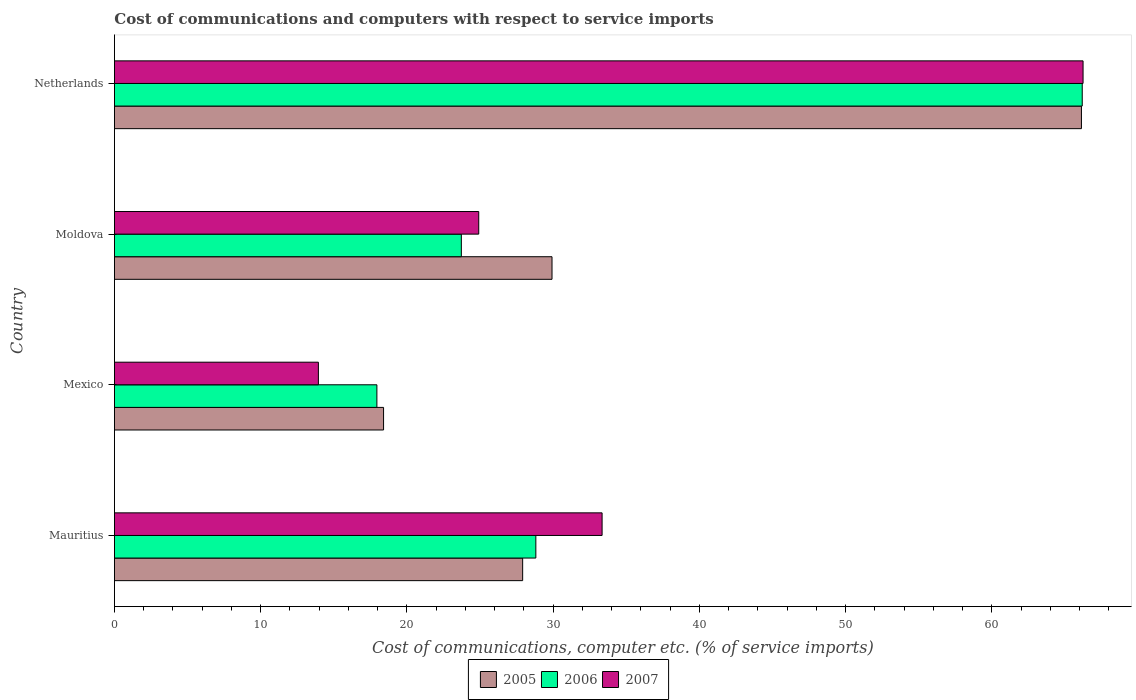How many groups of bars are there?
Ensure brevity in your answer.  4. How many bars are there on the 4th tick from the top?
Give a very brief answer. 3. What is the label of the 1st group of bars from the top?
Your response must be concise. Netherlands. In how many cases, is the number of bars for a given country not equal to the number of legend labels?
Offer a very short reply. 0. What is the cost of communications and computers in 2006 in Mauritius?
Your response must be concise. 28.82. Across all countries, what is the maximum cost of communications and computers in 2006?
Make the answer very short. 66.18. Across all countries, what is the minimum cost of communications and computers in 2005?
Provide a short and direct response. 18.4. What is the total cost of communications and computers in 2007 in the graph?
Ensure brevity in your answer.  138.43. What is the difference between the cost of communications and computers in 2005 in Mexico and that in Netherlands?
Offer a terse response. -47.72. What is the difference between the cost of communications and computers in 2006 in Mauritius and the cost of communications and computers in 2007 in Mexico?
Ensure brevity in your answer.  14.87. What is the average cost of communications and computers in 2005 per country?
Offer a terse response. 35.59. What is the difference between the cost of communications and computers in 2005 and cost of communications and computers in 2007 in Netherlands?
Give a very brief answer. -0.11. What is the ratio of the cost of communications and computers in 2007 in Mauritius to that in Moldova?
Provide a short and direct response. 1.34. Is the difference between the cost of communications and computers in 2005 in Mauritius and Mexico greater than the difference between the cost of communications and computers in 2007 in Mauritius and Mexico?
Your answer should be very brief. No. What is the difference between the highest and the second highest cost of communications and computers in 2007?
Provide a succinct answer. 32.89. What is the difference between the highest and the lowest cost of communications and computers in 2007?
Your answer should be compact. 52.29. In how many countries, is the cost of communications and computers in 2007 greater than the average cost of communications and computers in 2007 taken over all countries?
Provide a succinct answer. 1. Is the sum of the cost of communications and computers in 2005 in Mauritius and Moldova greater than the maximum cost of communications and computers in 2006 across all countries?
Keep it short and to the point. No. What does the 3rd bar from the top in Moldova represents?
Provide a short and direct response. 2005. Is it the case that in every country, the sum of the cost of communications and computers in 2007 and cost of communications and computers in 2005 is greater than the cost of communications and computers in 2006?
Offer a very short reply. Yes. How many bars are there?
Offer a terse response. 12. Are all the bars in the graph horizontal?
Ensure brevity in your answer.  Yes. How many countries are there in the graph?
Give a very brief answer. 4. What is the difference between two consecutive major ticks on the X-axis?
Provide a short and direct response. 10. Where does the legend appear in the graph?
Offer a very short reply. Bottom center. How are the legend labels stacked?
Keep it short and to the point. Horizontal. What is the title of the graph?
Give a very brief answer. Cost of communications and computers with respect to service imports. Does "2008" appear as one of the legend labels in the graph?
Give a very brief answer. No. What is the label or title of the X-axis?
Give a very brief answer. Cost of communications, computer etc. (% of service imports). What is the Cost of communications, computer etc. (% of service imports) of 2005 in Mauritius?
Provide a short and direct response. 27.91. What is the Cost of communications, computer etc. (% of service imports) of 2006 in Mauritius?
Your response must be concise. 28.82. What is the Cost of communications, computer etc. (% of service imports) in 2007 in Mauritius?
Your answer should be very brief. 33.35. What is the Cost of communications, computer etc. (% of service imports) in 2005 in Mexico?
Offer a terse response. 18.4. What is the Cost of communications, computer etc. (% of service imports) of 2006 in Mexico?
Keep it short and to the point. 17.95. What is the Cost of communications, computer etc. (% of service imports) of 2007 in Mexico?
Your answer should be very brief. 13.95. What is the Cost of communications, computer etc. (% of service imports) of 2005 in Moldova?
Provide a short and direct response. 29.92. What is the Cost of communications, computer etc. (% of service imports) of 2006 in Moldova?
Keep it short and to the point. 23.72. What is the Cost of communications, computer etc. (% of service imports) of 2007 in Moldova?
Your answer should be compact. 24.91. What is the Cost of communications, computer etc. (% of service imports) of 2005 in Netherlands?
Give a very brief answer. 66.12. What is the Cost of communications, computer etc. (% of service imports) of 2006 in Netherlands?
Keep it short and to the point. 66.18. What is the Cost of communications, computer etc. (% of service imports) of 2007 in Netherlands?
Make the answer very short. 66.23. Across all countries, what is the maximum Cost of communications, computer etc. (% of service imports) in 2005?
Keep it short and to the point. 66.12. Across all countries, what is the maximum Cost of communications, computer etc. (% of service imports) of 2006?
Your response must be concise. 66.18. Across all countries, what is the maximum Cost of communications, computer etc. (% of service imports) in 2007?
Provide a succinct answer. 66.23. Across all countries, what is the minimum Cost of communications, computer etc. (% of service imports) in 2005?
Provide a short and direct response. 18.4. Across all countries, what is the minimum Cost of communications, computer etc. (% of service imports) in 2006?
Provide a succinct answer. 17.95. Across all countries, what is the minimum Cost of communications, computer etc. (% of service imports) of 2007?
Keep it short and to the point. 13.95. What is the total Cost of communications, computer etc. (% of service imports) of 2005 in the graph?
Make the answer very short. 142.36. What is the total Cost of communications, computer etc. (% of service imports) of 2006 in the graph?
Your answer should be compact. 136.66. What is the total Cost of communications, computer etc. (% of service imports) in 2007 in the graph?
Provide a succinct answer. 138.43. What is the difference between the Cost of communications, computer etc. (% of service imports) of 2005 in Mauritius and that in Mexico?
Provide a succinct answer. 9.51. What is the difference between the Cost of communications, computer etc. (% of service imports) in 2006 in Mauritius and that in Mexico?
Give a very brief answer. 10.87. What is the difference between the Cost of communications, computer etc. (% of service imports) in 2007 in Mauritius and that in Mexico?
Your answer should be very brief. 19.4. What is the difference between the Cost of communications, computer etc. (% of service imports) of 2005 in Mauritius and that in Moldova?
Give a very brief answer. -2.01. What is the difference between the Cost of communications, computer etc. (% of service imports) in 2006 in Mauritius and that in Moldova?
Provide a short and direct response. 5.09. What is the difference between the Cost of communications, computer etc. (% of service imports) in 2007 in Mauritius and that in Moldova?
Ensure brevity in your answer.  8.44. What is the difference between the Cost of communications, computer etc. (% of service imports) in 2005 in Mauritius and that in Netherlands?
Give a very brief answer. -38.21. What is the difference between the Cost of communications, computer etc. (% of service imports) in 2006 in Mauritius and that in Netherlands?
Make the answer very short. -37.36. What is the difference between the Cost of communications, computer etc. (% of service imports) in 2007 in Mauritius and that in Netherlands?
Ensure brevity in your answer.  -32.89. What is the difference between the Cost of communications, computer etc. (% of service imports) in 2005 in Mexico and that in Moldova?
Ensure brevity in your answer.  -11.52. What is the difference between the Cost of communications, computer etc. (% of service imports) of 2006 in Mexico and that in Moldova?
Offer a terse response. -5.77. What is the difference between the Cost of communications, computer etc. (% of service imports) of 2007 in Mexico and that in Moldova?
Your response must be concise. -10.96. What is the difference between the Cost of communications, computer etc. (% of service imports) of 2005 in Mexico and that in Netherlands?
Your answer should be very brief. -47.72. What is the difference between the Cost of communications, computer etc. (% of service imports) in 2006 in Mexico and that in Netherlands?
Your answer should be compact. -48.23. What is the difference between the Cost of communications, computer etc. (% of service imports) in 2007 in Mexico and that in Netherlands?
Your response must be concise. -52.29. What is the difference between the Cost of communications, computer etc. (% of service imports) in 2005 in Moldova and that in Netherlands?
Make the answer very short. -36.2. What is the difference between the Cost of communications, computer etc. (% of service imports) in 2006 in Moldova and that in Netherlands?
Provide a succinct answer. -42.46. What is the difference between the Cost of communications, computer etc. (% of service imports) in 2007 in Moldova and that in Netherlands?
Your response must be concise. -41.32. What is the difference between the Cost of communications, computer etc. (% of service imports) in 2005 in Mauritius and the Cost of communications, computer etc. (% of service imports) in 2006 in Mexico?
Keep it short and to the point. 9.97. What is the difference between the Cost of communications, computer etc. (% of service imports) of 2005 in Mauritius and the Cost of communications, computer etc. (% of service imports) of 2007 in Mexico?
Keep it short and to the point. 13.97. What is the difference between the Cost of communications, computer etc. (% of service imports) in 2006 in Mauritius and the Cost of communications, computer etc. (% of service imports) in 2007 in Mexico?
Give a very brief answer. 14.87. What is the difference between the Cost of communications, computer etc. (% of service imports) in 2005 in Mauritius and the Cost of communications, computer etc. (% of service imports) in 2006 in Moldova?
Offer a terse response. 4.19. What is the difference between the Cost of communications, computer etc. (% of service imports) in 2005 in Mauritius and the Cost of communications, computer etc. (% of service imports) in 2007 in Moldova?
Offer a terse response. 3. What is the difference between the Cost of communications, computer etc. (% of service imports) in 2006 in Mauritius and the Cost of communications, computer etc. (% of service imports) in 2007 in Moldova?
Provide a short and direct response. 3.91. What is the difference between the Cost of communications, computer etc. (% of service imports) of 2005 in Mauritius and the Cost of communications, computer etc. (% of service imports) of 2006 in Netherlands?
Give a very brief answer. -38.26. What is the difference between the Cost of communications, computer etc. (% of service imports) in 2005 in Mauritius and the Cost of communications, computer etc. (% of service imports) in 2007 in Netherlands?
Your answer should be compact. -38.32. What is the difference between the Cost of communications, computer etc. (% of service imports) in 2006 in Mauritius and the Cost of communications, computer etc. (% of service imports) in 2007 in Netherlands?
Offer a terse response. -37.42. What is the difference between the Cost of communications, computer etc. (% of service imports) of 2005 in Mexico and the Cost of communications, computer etc. (% of service imports) of 2006 in Moldova?
Offer a very short reply. -5.32. What is the difference between the Cost of communications, computer etc. (% of service imports) in 2005 in Mexico and the Cost of communications, computer etc. (% of service imports) in 2007 in Moldova?
Your answer should be compact. -6.51. What is the difference between the Cost of communications, computer etc. (% of service imports) in 2006 in Mexico and the Cost of communications, computer etc. (% of service imports) in 2007 in Moldova?
Provide a short and direct response. -6.96. What is the difference between the Cost of communications, computer etc. (% of service imports) of 2005 in Mexico and the Cost of communications, computer etc. (% of service imports) of 2006 in Netherlands?
Offer a terse response. -47.77. What is the difference between the Cost of communications, computer etc. (% of service imports) in 2005 in Mexico and the Cost of communications, computer etc. (% of service imports) in 2007 in Netherlands?
Your answer should be very brief. -47.83. What is the difference between the Cost of communications, computer etc. (% of service imports) in 2006 in Mexico and the Cost of communications, computer etc. (% of service imports) in 2007 in Netherlands?
Provide a succinct answer. -48.29. What is the difference between the Cost of communications, computer etc. (% of service imports) of 2005 in Moldova and the Cost of communications, computer etc. (% of service imports) of 2006 in Netherlands?
Offer a terse response. -36.26. What is the difference between the Cost of communications, computer etc. (% of service imports) of 2005 in Moldova and the Cost of communications, computer etc. (% of service imports) of 2007 in Netherlands?
Give a very brief answer. -36.31. What is the difference between the Cost of communications, computer etc. (% of service imports) in 2006 in Moldova and the Cost of communications, computer etc. (% of service imports) in 2007 in Netherlands?
Provide a succinct answer. -42.51. What is the average Cost of communications, computer etc. (% of service imports) of 2005 per country?
Your answer should be compact. 35.59. What is the average Cost of communications, computer etc. (% of service imports) of 2006 per country?
Ensure brevity in your answer.  34.16. What is the average Cost of communications, computer etc. (% of service imports) in 2007 per country?
Provide a short and direct response. 34.61. What is the difference between the Cost of communications, computer etc. (% of service imports) of 2005 and Cost of communications, computer etc. (% of service imports) of 2006 in Mauritius?
Make the answer very short. -0.9. What is the difference between the Cost of communications, computer etc. (% of service imports) in 2005 and Cost of communications, computer etc. (% of service imports) in 2007 in Mauritius?
Your answer should be compact. -5.43. What is the difference between the Cost of communications, computer etc. (% of service imports) of 2006 and Cost of communications, computer etc. (% of service imports) of 2007 in Mauritius?
Provide a short and direct response. -4.53. What is the difference between the Cost of communications, computer etc. (% of service imports) in 2005 and Cost of communications, computer etc. (% of service imports) in 2006 in Mexico?
Make the answer very short. 0.46. What is the difference between the Cost of communications, computer etc. (% of service imports) of 2005 and Cost of communications, computer etc. (% of service imports) of 2007 in Mexico?
Your answer should be very brief. 4.46. What is the difference between the Cost of communications, computer etc. (% of service imports) in 2006 and Cost of communications, computer etc. (% of service imports) in 2007 in Mexico?
Make the answer very short. 4. What is the difference between the Cost of communications, computer etc. (% of service imports) of 2005 and Cost of communications, computer etc. (% of service imports) of 2006 in Moldova?
Your answer should be compact. 6.2. What is the difference between the Cost of communications, computer etc. (% of service imports) of 2005 and Cost of communications, computer etc. (% of service imports) of 2007 in Moldova?
Provide a short and direct response. 5.01. What is the difference between the Cost of communications, computer etc. (% of service imports) in 2006 and Cost of communications, computer etc. (% of service imports) in 2007 in Moldova?
Your answer should be very brief. -1.19. What is the difference between the Cost of communications, computer etc. (% of service imports) of 2005 and Cost of communications, computer etc. (% of service imports) of 2006 in Netherlands?
Provide a succinct answer. -0.05. What is the difference between the Cost of communications, computer etc. (% of service imports) in 2005 and Cost of communications, computer etc. (% of service imports) in 2007 in Netherlands?
Your response must be concise. -0.11. What is the difference between the Cost of communications, computer etc. (% of service imports) of 2006 and Cost of communications, computer etc. (% of service imports) of 2007 in Netherlands?
Keep it short and to the point. -0.06. What is the ratio of the Cost of communications, computer etc. (% of service imports) of 2005 in Mauritius to that in Mexico?
Give a very brief answer. 1.52. What is the ratio of the Cost of communications, computer etc. (% of service imports) of 2006 in Mauritius to that in Mexico?
Your answer should be very brief. 1.61. What is the ratio of the Cost of communications, computer etc. (% of service imports) of 2007 in Mauritius to that in Mexico?
Your answer should be compact. 2.39. What is the ratio of the Cost of communications, computer etc. (% of service imports) of 2005 in Mauritius to that in Moldova?
Offer a very short reply. 0.93. What is the ratio of the Cost of communications, computer etc. (% of service imports) in 2006 in Mauritius to that in Moldova?
Offer a very short reply. 1.21. What is the ratio of the Cost of communications, computer etc. (% of service imports) in 2007 in Mauritius to that in Moldova?
Offer a terse response. 1.34. What is the ratio of the Cost of communications, computer etc. (% of service imports) of 2005 in Mauritius to that in Netherlands?
Ensure brevity in your answer.  0.42. What is the ratio of the Cost of communications, computer etc. (% of service imports) in 2006 in Mauritius to that in Netherlands?
Your answer should be compact. 0.44. What is the ratio of the Cost of communications, computer etc. (% of service imports) of 2007 in Mauritius to that in Netherlands?
Your response must be concise. 0.5. What is the ratio of the Cost of communications, computer etc. (% of service imports) in 2005 in Mexico to that in Moldova?
Offer a very short reply. 0.61. What is the ratio of the Cost of communications, computer etc. (% of service imports) in 2006 in Mexico to that in Moldova?
Keep it short and to the point. 0.76. What is the ratio of the Cost of communications, computer etc. (% of service imports) of 2007 in Mexico to that in Moldova?
Provide a short and direct response. 0.56. What is the ratio of the Cost of communications, computer etc. (% of service imports) in 2005 in Mexico to that in Netherlands?
Offer a very short reply. 0.28. What is the ratio of the Cost of communications, computer etc. (% of service imports) of 2006 in Mexico to that in Netherlands?
Your answer should be very brief. 0.27. What is the ratio of the Cost of communications, computer etc. (% of service imports) of 2007 in Mexico to that in Netherlands?
Your answer should be very brief. 0.21. What is the ratio of the Cost of communications, computer etc. (% of service imports) of 2005 in Moldova to that in Netherlands?
Give a very brief answer. 0.45. What is the ratio of the Cost of communications, computer etc. (% of service imports) of 2006 in Moldova to that in Netherlands?
Your answer should be very brief. 0.36. What is the ratio of the Cost of communications, computer etc. (% of service imports) in 2007 in Moldova to that in Netherlands?
Provide a succinct answer. 0.38. What is the difference between the highest and the second highest Cost of communications, computer etc. (% of service imports) in 2005?
Ensure brevity in your answer.  36.2. What is the difference between the highest and the second highest Cost of communications, computer etc. (% of service imports) of 2006?
Make the answer very short. 37.36. What is the difference between the highest and the second highest Cost of communications, computer etc. (% of service imports) of 2007?
Provide a succinct answer. 32.89. What is the difference between the highest and the lowest Cost of communications, computer etc. (% of service imports) in 2005?
Your answer should be compact. 47.72. What is the difference between the highest and the lowest Cost of communications, computer etc. (% of service imports) of 2006?
Provide a short and direct response. 48.23. What is the difference between the highest and the lowest Cost of communications, computer etc. (% of service imports) in 2007?
Your answer should be compact. 52.29. 